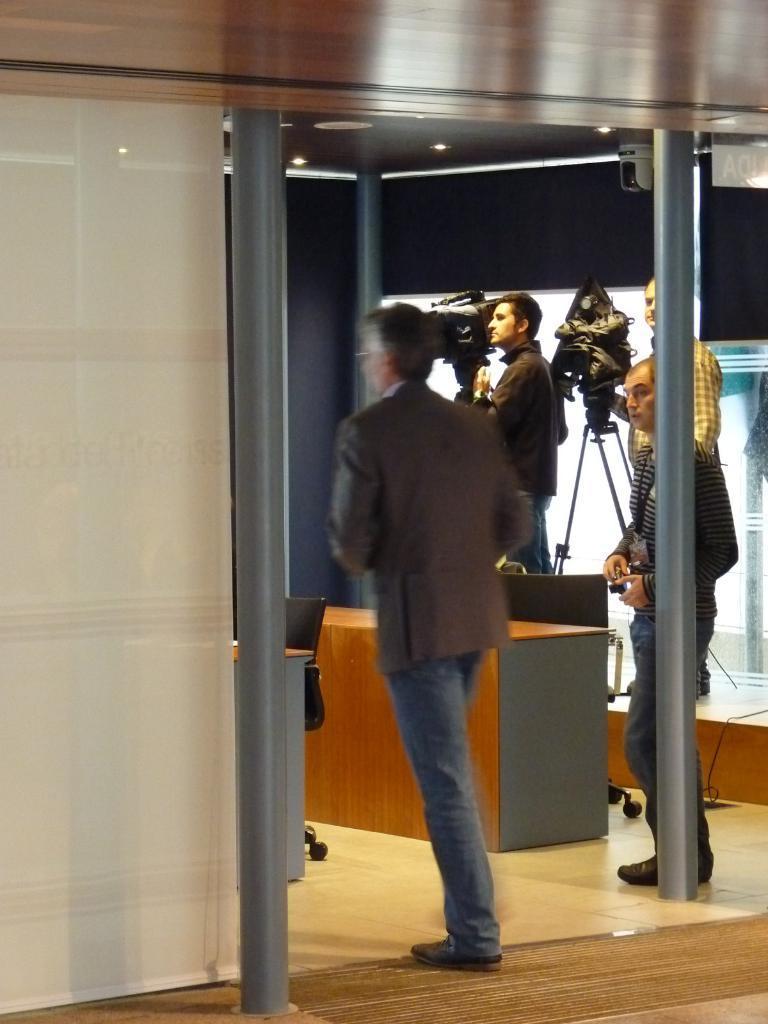Can you describe this image briefly? In this picture we can see a man walking here, in the background there are three people standing, we can see the ceiling at the top of the picture, there is a chair and desk here. 